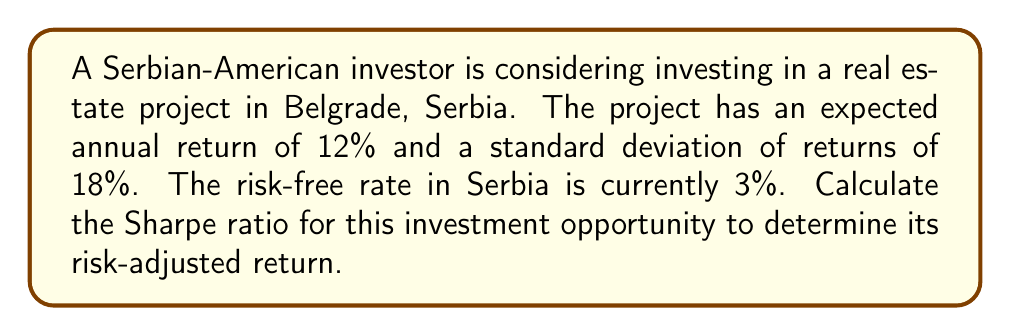Solve this math problem. To calculate the risk-adjusted return using the Sharpe ratio, we need to follow these steps:

1. Identify the given information:
   - Expected annual return (R) = 12%
   - Standard deviation of returns (σ) = 18%
   - Risk-free rate (Rf) = 3%

2. The Sharpe ratio is calculated using the following formula:
   
   $$ \text{Sharpe Ratio} = \frac{R - R_f}{\sigma} $$

   Where:
   R = Expected return of the investment
   Rf = Risk-free rate
   σ = Standard deviation of the investment's returns

3. Subtract the risk-free rate from the expected return:
   
   $$ R - R_f = 12\% - 3\% = 9\% $$

4. Divide the result by the standard deviation:
   
   $$ \text{Sharpe Ratio} = \frac{9\%}{18\%} = 0.5 $$

The Sharpe ratio of 0.5 indicates the risk-adjusted return of the investment. A higher Sharpe ratio suggests better risk-adjusted performance. In this case, the investment is providing 0.5 units of excess return per unit of risk.
Answer: The Sharpe ratio for the Serbian real estate project is 0.5. 